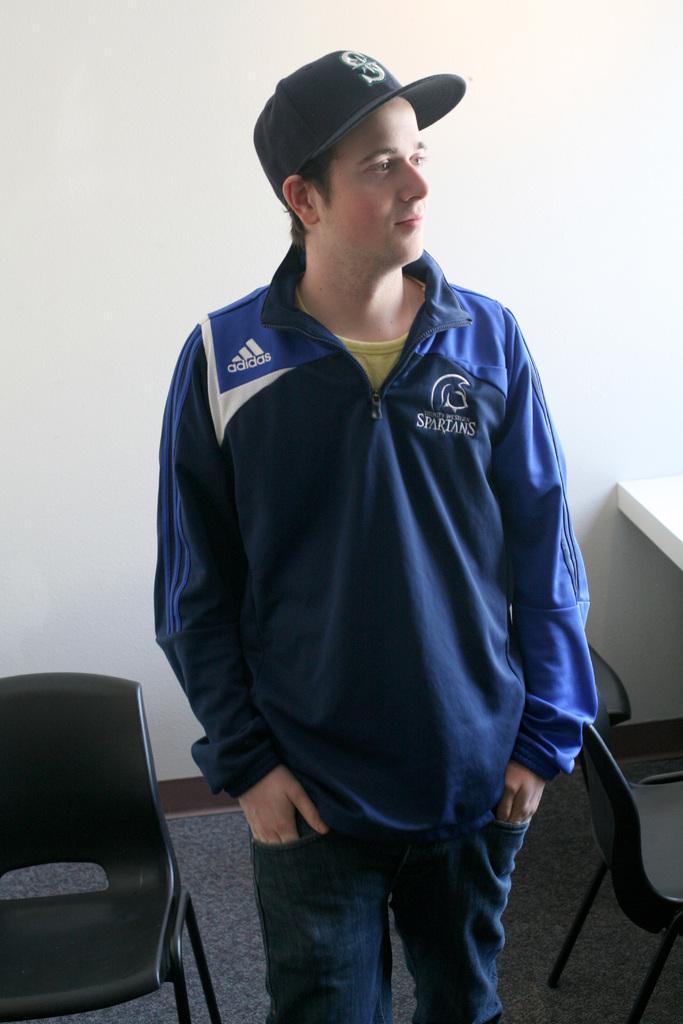Describe this image in one or two sentences. Here we have a man who is wearing blue jacket and black jean, he also wears a cap. He is looking somewhere. Also we have chairs, some desk here. This seems like some room. 